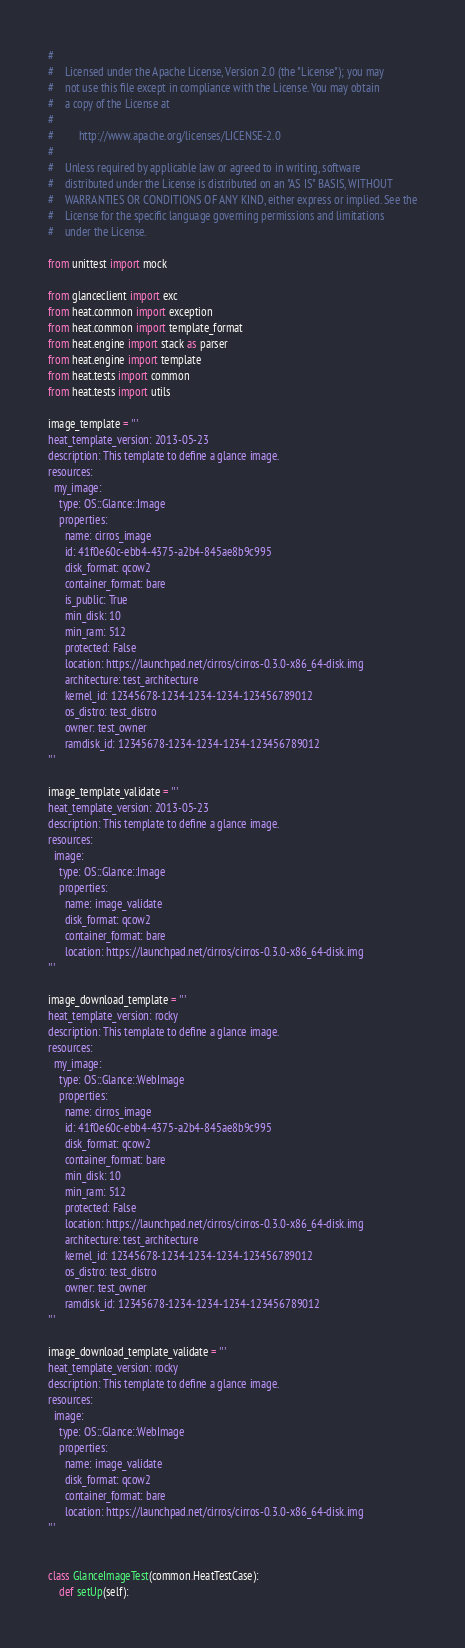<code> <loc_0><loc_0><loc_500><loc_500><_Python_>#
#    Licensed under the Apache License, Version 2.0 (the "License"); you may
#    not use this file except in compliance with the License. You may obtain
#    a copy of the License at
#
#         http://www.apache.org/licenses/LICENSE-2.0
#
#    Unless required by applicable law or agreed to in writing, software
#    distributed under the License is distributed on an "AS IS" BASIS, WITHOUT
#    WARRANTIES OR CONDITIONS OF ANY KIND, either express or implied. See the
#    License for the specific language governing permissions and limitations
#    under the License.

from unittest import mock

from glanceclient import exc
from heat.common import exception
from heat.common import template_format
from heat.engine import stack as parser
from heat.engine import template
from heat.tests import common
from heat.tests import utils

image_template = '''
heat_template_version: 2013-05-23
description: This template to define a glance image.
resources:
  my_image:
    type: OS::Glance::Image
    properties:
      name: cirros_image
      id: 41f0e60c-ebb4-4375-a2b4-845ae8b9c995
      disk_format: qcow2
      container_format: bare
      is_public: True
      min_disk: 10
      min_ram: 512
      protected: False
      location: https://launchpad.net/cirros/cirros-0.3.0-x86_64-disk.img
      architecture: test_architecture
      kernel_id: 12345678-1234-1234-1234-123456789012
      os_distro: test_distro
      owner: test_owner
      ramdisk_id: 12345678-1234-1234-1234-123456789012
'''

image_template_validate = '''
heat_template_version: 2013-05-23
description: This template to define a glance image.
resources:
  image:
    type: OS::Glance::Image
    properties:
      name: image_validate
      disk_format: qcow2
      container_format: bare
      location: https://launchpad.net/cirros/cirros-0.3.0-x86_64-disk.img
'''

image_download_template = '''
heat_template_version: rocky
description: This template to define a glance image.
resources:
  my_image:
    type: OS::Glance::WebImage
    properties:
      name: cirros_image
      id: 41f0e60c-ebb4-4375-a2b4-845ae8b9c995
      disk_format: qcow2
      container_format: bare
      min_disk: 10
      min_ram: 512
      protected: False
      location: https://launchpad.net/cirros/cirros-0.3.0-x86_64-disk.img
      architecture: test_architecture
      kernel_id: 12345678-1234-1234-1234-123456789012
      os_distro: test_distro
      owner: test_owner
      ramdisk_id: 12345678-1234-1234-1234-123456789012
'''

image_download_template_validate = '''
heat_template_version: rocky
description: This template to define a glance image.
resources:
  image:
    type: OS::Glance::WebImage
    properties:
      name: image_validate
      disk_format: qcow2
      container_format: bare
      location: https://launchpad.net/cirros/cirros-0.3.0-x86_64-disk.img
'''


class GlanceImageTest(common.HeatTestCase):
    def setUp(self):</code> 